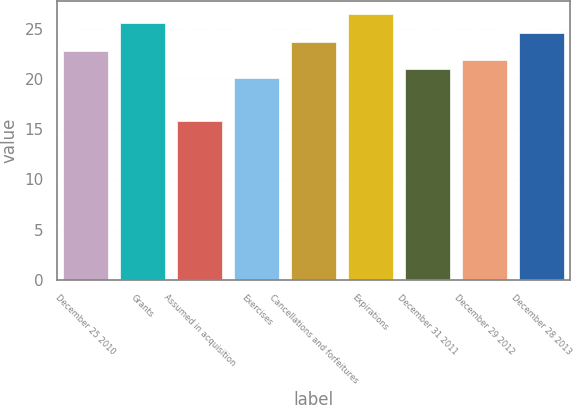Convert chart. <chart><loc_0><loc_0><loc_500><loc_500><bar_chart><fcel>December 25 2010<fcel>Grants<fcel>Assumed in acquisition<fcel>Exercises<fcel>Cancellations and forfeitures<fcel>Expirations<fcel>December 31 2011<fcel>December 29 2012<fcel>December 28 2013<nl><fcel>22.78<fcel>25.51<fcel>15.8<fcel>20.06<fcel>23.69<fcel>26.42<fcel>20.96<fcel>21.87<fcel>24.6<nl></chart> 